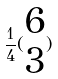Convert formula to latex. <formula><loc_0><loc_0><loc_500><loc_500>\frac { 1 } { 4 } ( \begin{matrix} 6 \\ 3 \end{matrix} )</formula> 